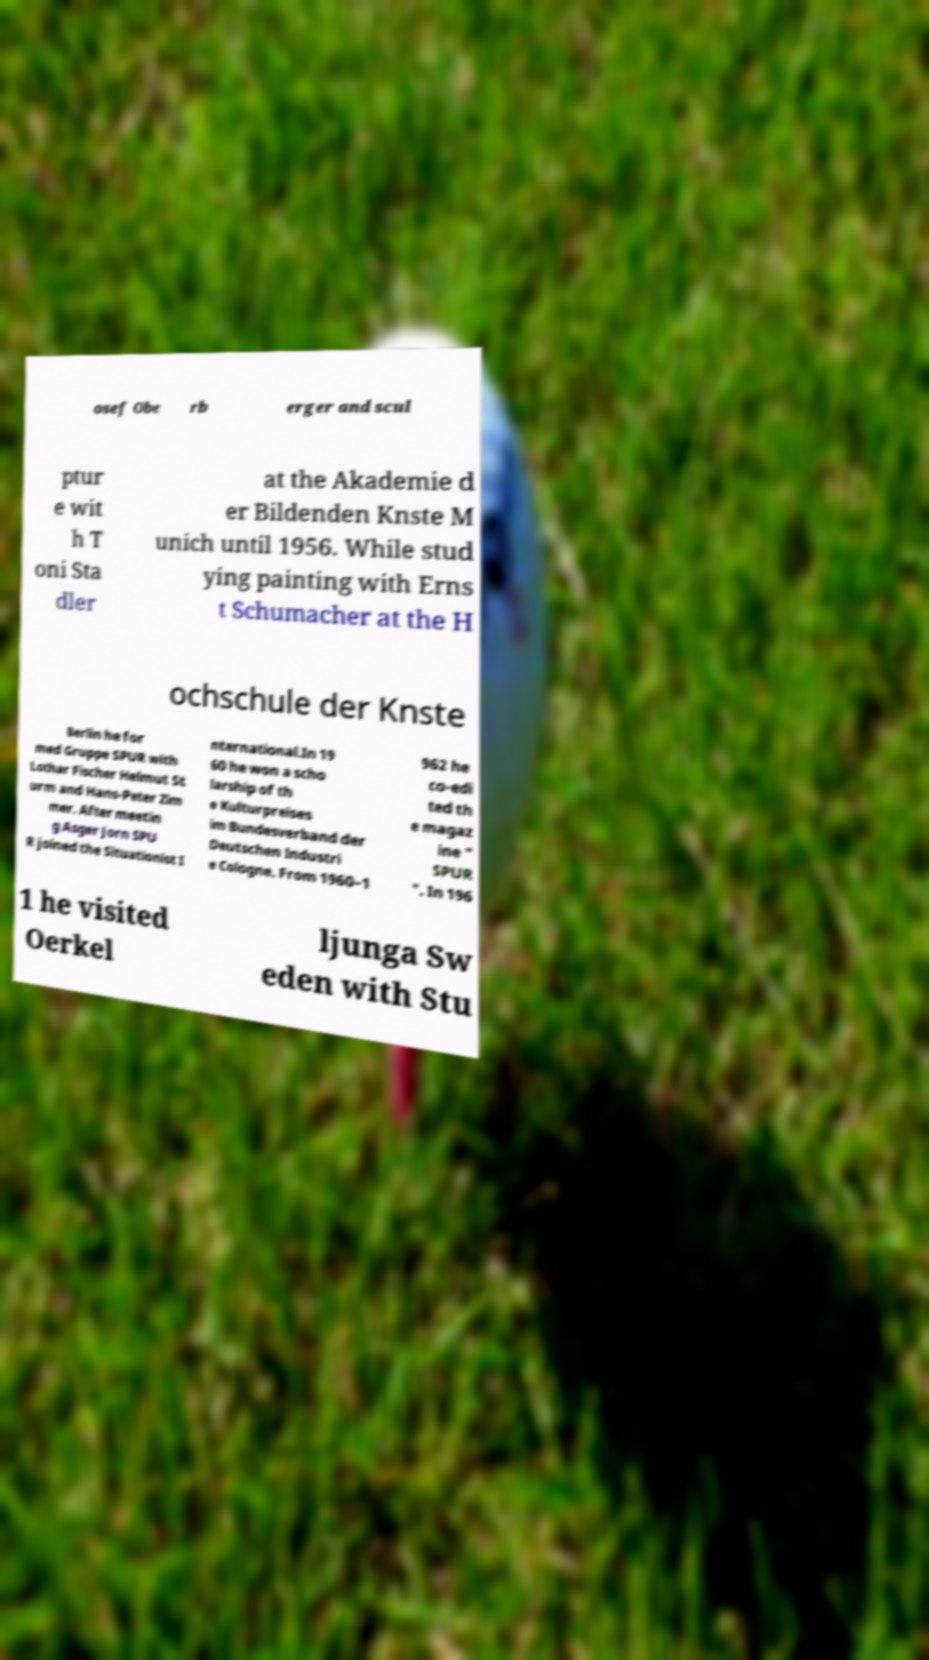For documentation purposes, I need the text within this image transcribed. Could you provide that? osef Obe rb erger and scul ptur e wit h T oni Sta dler at the Akademie d er Bildenden Knste M unich until 1956. While stud ying painting with Erns t Schumacher at the H ochschule der Knste Berlin he for med Gruppe SPUR with Lothar Fischer Helmut St urm and Hans-Peter Zim mer. After meetin g Asger Jorn SPU R joined the Situationist I nternational.In 19 60 he won a scho larship of th e Kulturpreises im Bundesverband der Deutschen Industri e Cologne. From 1960–1 962 he co-edi ted th e magaz ine " SPUR ". In 196 1 he visited Oerkel ljunga Sw eden with Stu 